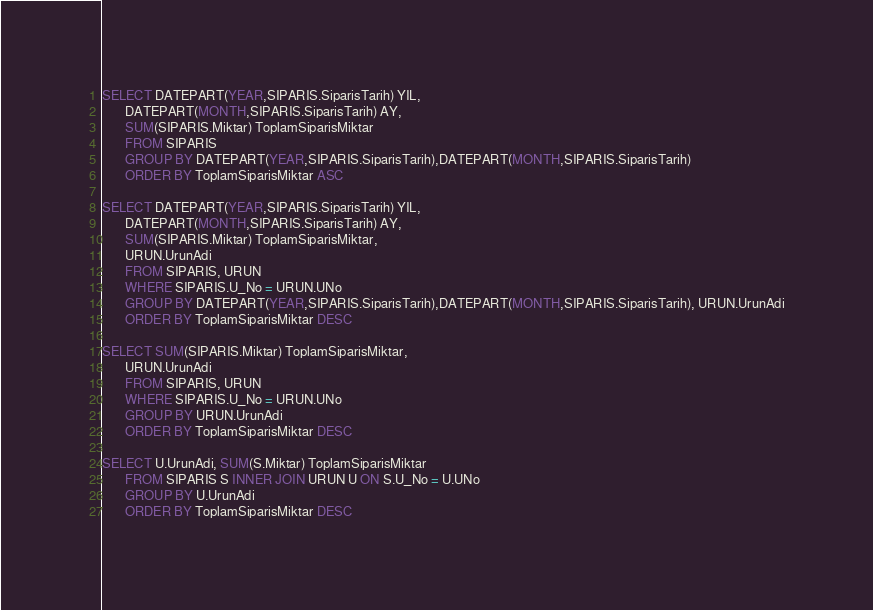Convert code to text. <code><loc_0><loc_0><loc_500><loc_500><_SQL_>SELECT DATEPART(YEAR,SIPARIS.SiparisTarih) YIL,
	   DATEPART(MONTH,SIPARIS.SiparisTarih) AY,
	   SUM(SIPARIS.Miktar) ToplamSiparisMiktar 
	   FROM SIPARIS
	   GROUP BY DATEPART(YEAR,SIPARIS.SiparisTarih),DATEPART(MONTH,SIPARIS.SiparisTarih) 
	   ORDER BY ToplamSiparisMiktar ASC

SELECT DATEPART(YEAR,SIPARIS.SiparisTarih) YIL,
	   DATEPART(MONTH,SIPARIS.SiparisTarih) AY,
	   SUM(SIPARIS.Miktar) ToplamSiparisMiktar,
	   URUN.UrunAdi
	   FROM SIPARIS, URUN
	   WHERE SIPARIS.U_No = URUN.UNo
	   GROUP BY DATEPART(YEAR,SIPARIS.SiparisTarih),DATEPART(MONTH,SIPARIS.SiparisTarih), URUN.UrunAdi
	   ORDER BY ToplamSiparisMiktar DESC

SELECT SUM(SIPARIS.Miktar) ToplamSiparisMiktar,
	   URUN.UrunAdi
	   FROM SIPARIS, URUN
	   WHERE SIPARIS.U_No = URUN.UNo
	   GROUP BY URUN.UrunAdi
	   ORDER BY ToplamSiparisMiktar DESC

SELECT U.UrunAdi, SUM(S.Miktar) ToplamSiparisMiktar
	   FROM SIPARIS S INNER JOIN URUN U ON S.U_No = U.UNo
	   GROUP BY U.UrunAdi
	   ORDER BY ToplamSiparisMiktar DESC
</code> 